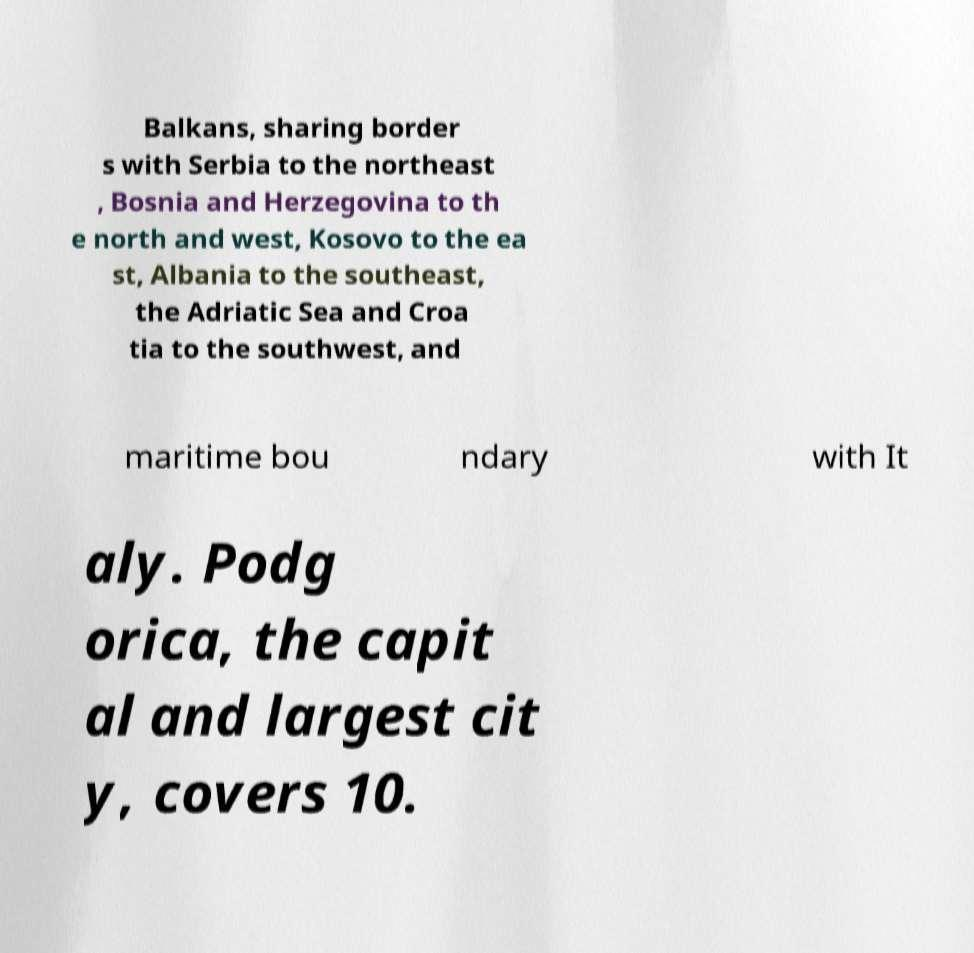For documentation purposes, I need the text within this image transcribed. Could you provide that? Balkans, sharing border s with Serbia to the northeast , Bosnia and Herzegovina to th e north and west, Kosovo to the ea st, Albania to the southeast, the Adriatic Sea and Croa tia to the southwest, and maritime bou ndary with It aly. Podg orica, the capit al and largest cit y, covers 10. 